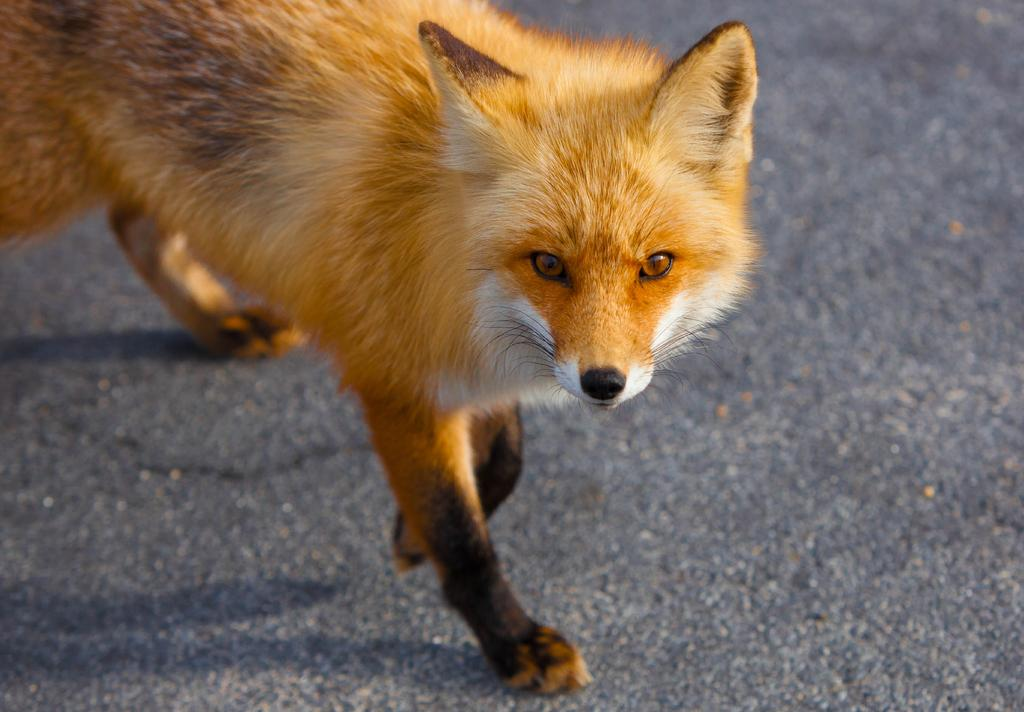What animal can be seen in the image? There is a fox in the image. What is the fox doing in the image? The fox is walking on the road. What attraction is the fox visiting in the image? There is no attraction present in the image; the fox is simply walking on the road. Is the fox holding an apple in the image? There is no apple present in the image; the fox is not holding anything. 